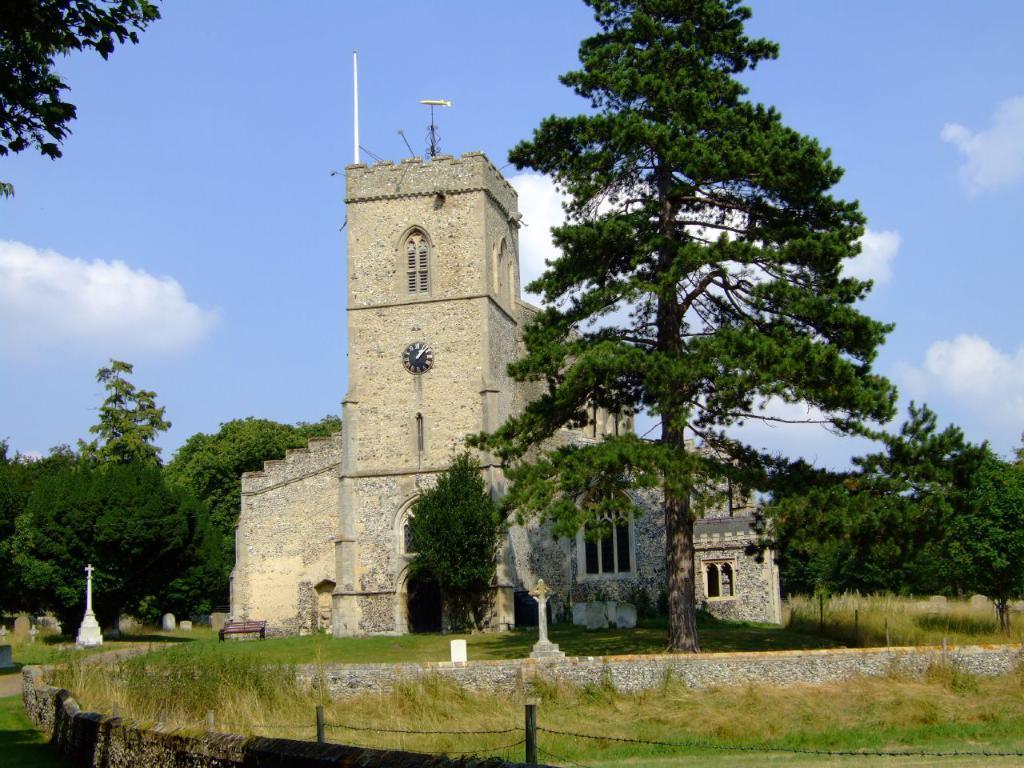In one or two sentences, can you explain what this image depicts? In this image we can see the wall, fence, grass, stone building, trees, wooden bench, and the blue color sky with clouds in the background. 